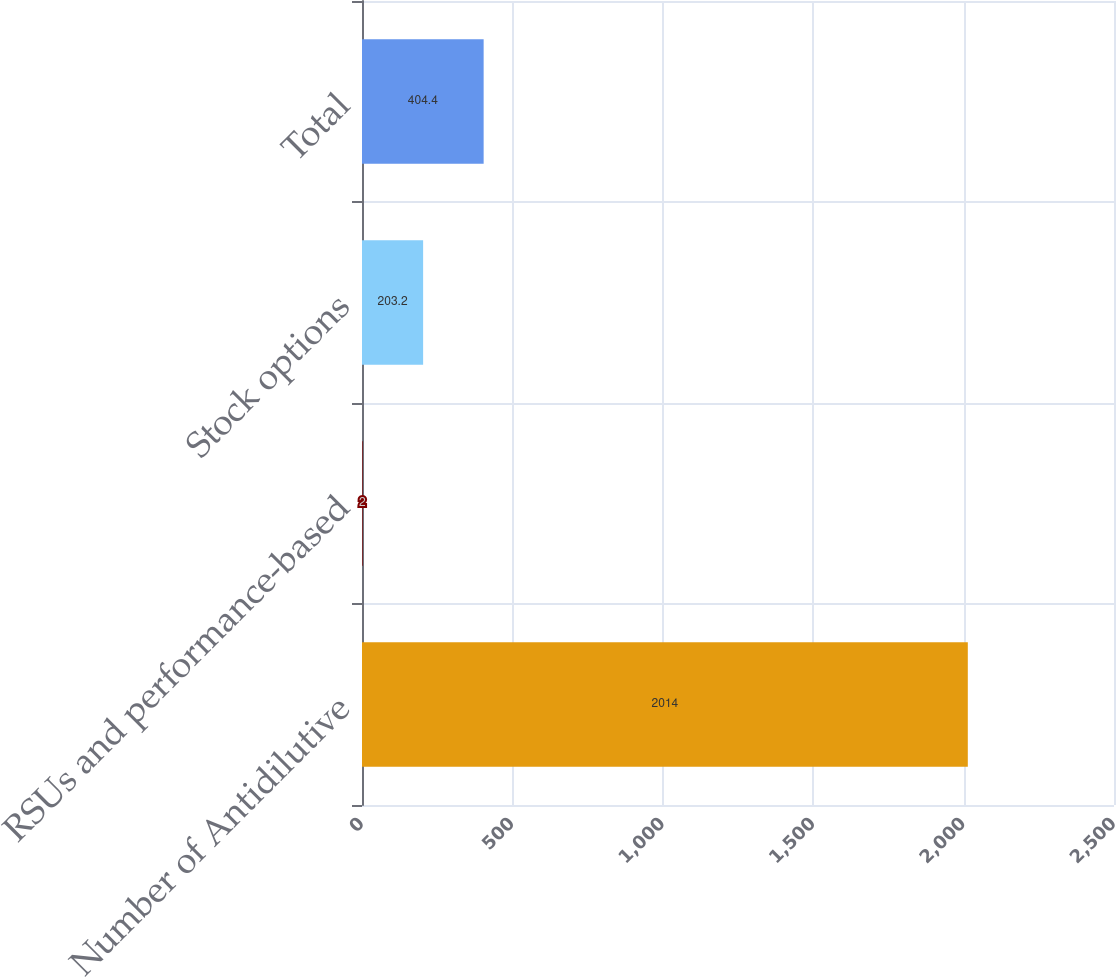<chart> <loc_0><loc_0><loc_500><loc_500><bar_chart><fcel>Number of Antidilutive<fcel>RSUs and performance-based<fcel>Stock options<fcel>Total<nl><fcel>2014<fcel>2<fcel>203.2<fcel>404.4<nl></chart> 